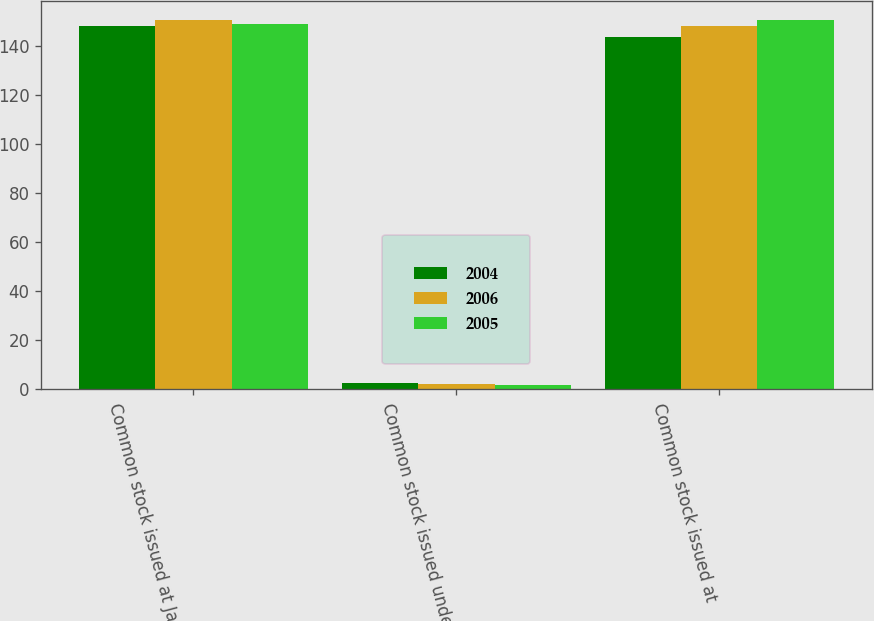Convert chart. <chart><loc_0><loc_0><loc_500><loc_500><stacked_bar_chart><ecel><fcel>Common stock issued at January<fcel>Common stock issued under<fcel>Common stock issued at<nl><fcel>2004<fcel>148<fcel>2.5<fcel>143.8<nl><fcel>2006<fcel>150.7<fcel>2.1<fcel>148<nl><fcel>2005<fcel>148.9<fcel>1.8<fcel>150.7<nl></chart> 